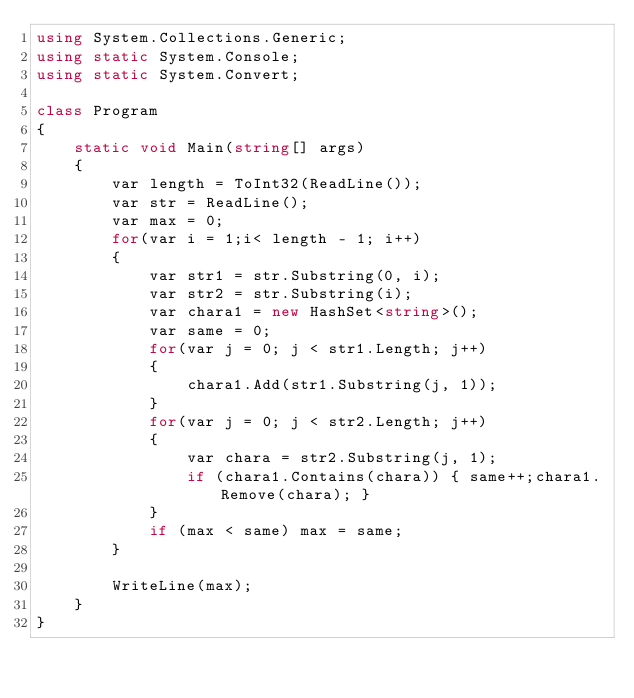Convert code to text. <code><loc_0><loc_0><loc_500><loc_500><_C#_>using System.Collections.Generic;
using static System.Console;
using static System.Convert;

class Program
{
    static void Main(string[] args)
    {
        var length = ToInt32(ReadLine());
        var str = ReadLine();
        var max = 0;
        for(var i = 1;i< length - 1; i++)
        {
            var str1 = str.Substring(0, i);
            var str2 = str.Substring(i);
            var chara1 = new HashSet<string>();
            var same = 0;
            for(var j = 0; j < str1.Length; j++)
            {
                chara1.Add(str1.Substring(j, 1));
            }
            for(var j = 0; j < str2.Length; j++)
            {
                var chara = str2.Substring(j, 1);
                if (chara1.Contains(chara)) { same++;chara1.Remove(chara); }
            }
            if (max < same) max = same;
        }

        WriteLine(max);
    }
}

</code> 